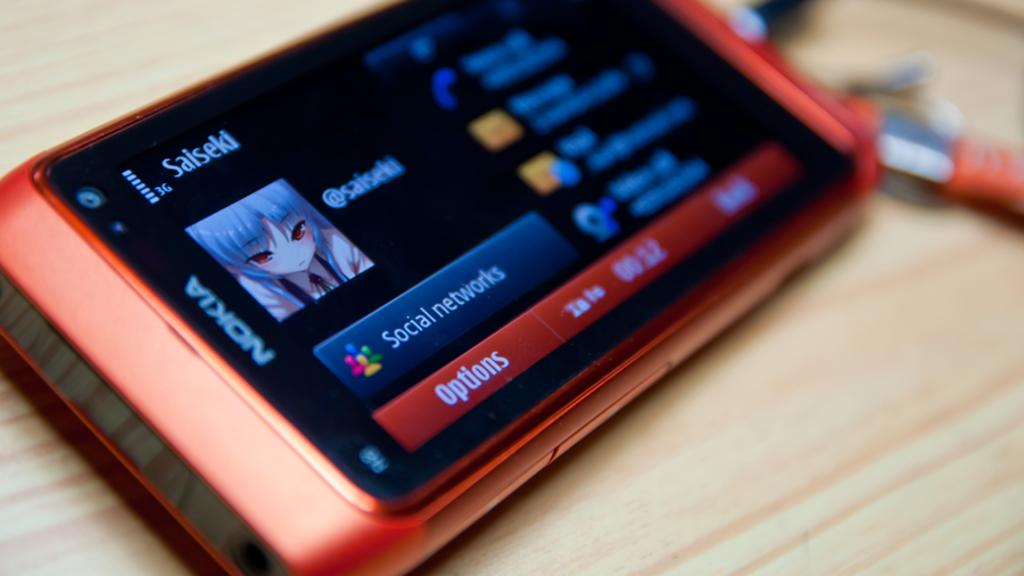<image>
Provide a brief description of the given image. An orange Nokia phone with multiple things pulled up on the display. 